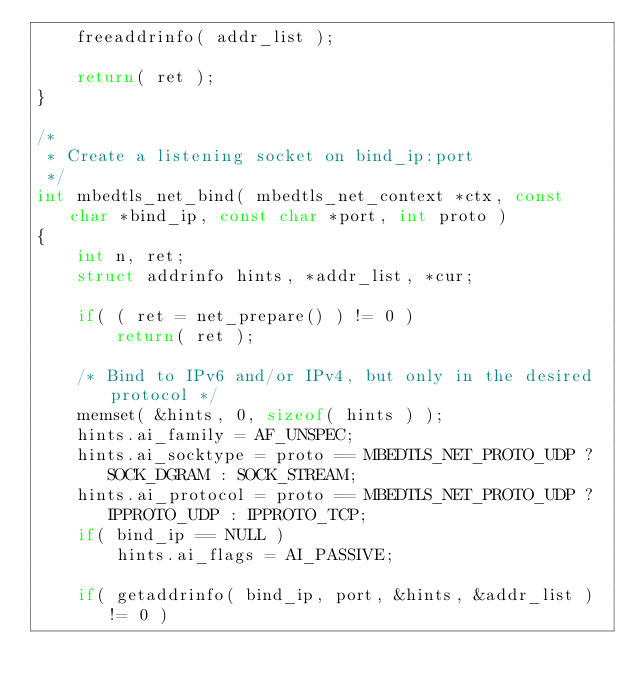<code> <loc_0><loc_0><loc_500><loc_500><_C_>    freeaddrinfo( addr_list );

    return( ret );
}

/*
 * Create a listening socket on bind_ip:port
 */
int mbedtls_net_bind( mbedtls_net_context *ctx, const char *bind_ip, const char *port, int proto )
{
    int n, ret;
    struct addrinfo hints, *addr_list, *cur;

    if( ( ret = net_prepare() ) != 0 )
        return( ret );

    /* Bind to IPv6 and/or IPv4, but only in the desired protocol */
    memset( &hints, 0, sizeof( hints ) );
    hints.ai_family = AF_UNSPEC;
    hints.ai_socktype = proto == MBEDTLS_NET_PROTO_UDP ? SOCK_DGRAM : SOCK_STREAM;
    hints.ai_protocol = proto == MBEDTLS_NET_PROTO_UDP ? IPPROTO_UDP : IPPROTO_TCP;
    if( bind_ip == NULL )
        hints.ai_flags = AI_PASSIVE;

    if( getaddrinfo( bind_ip, port, &hints, &addr_list ) != 0 )</code> 